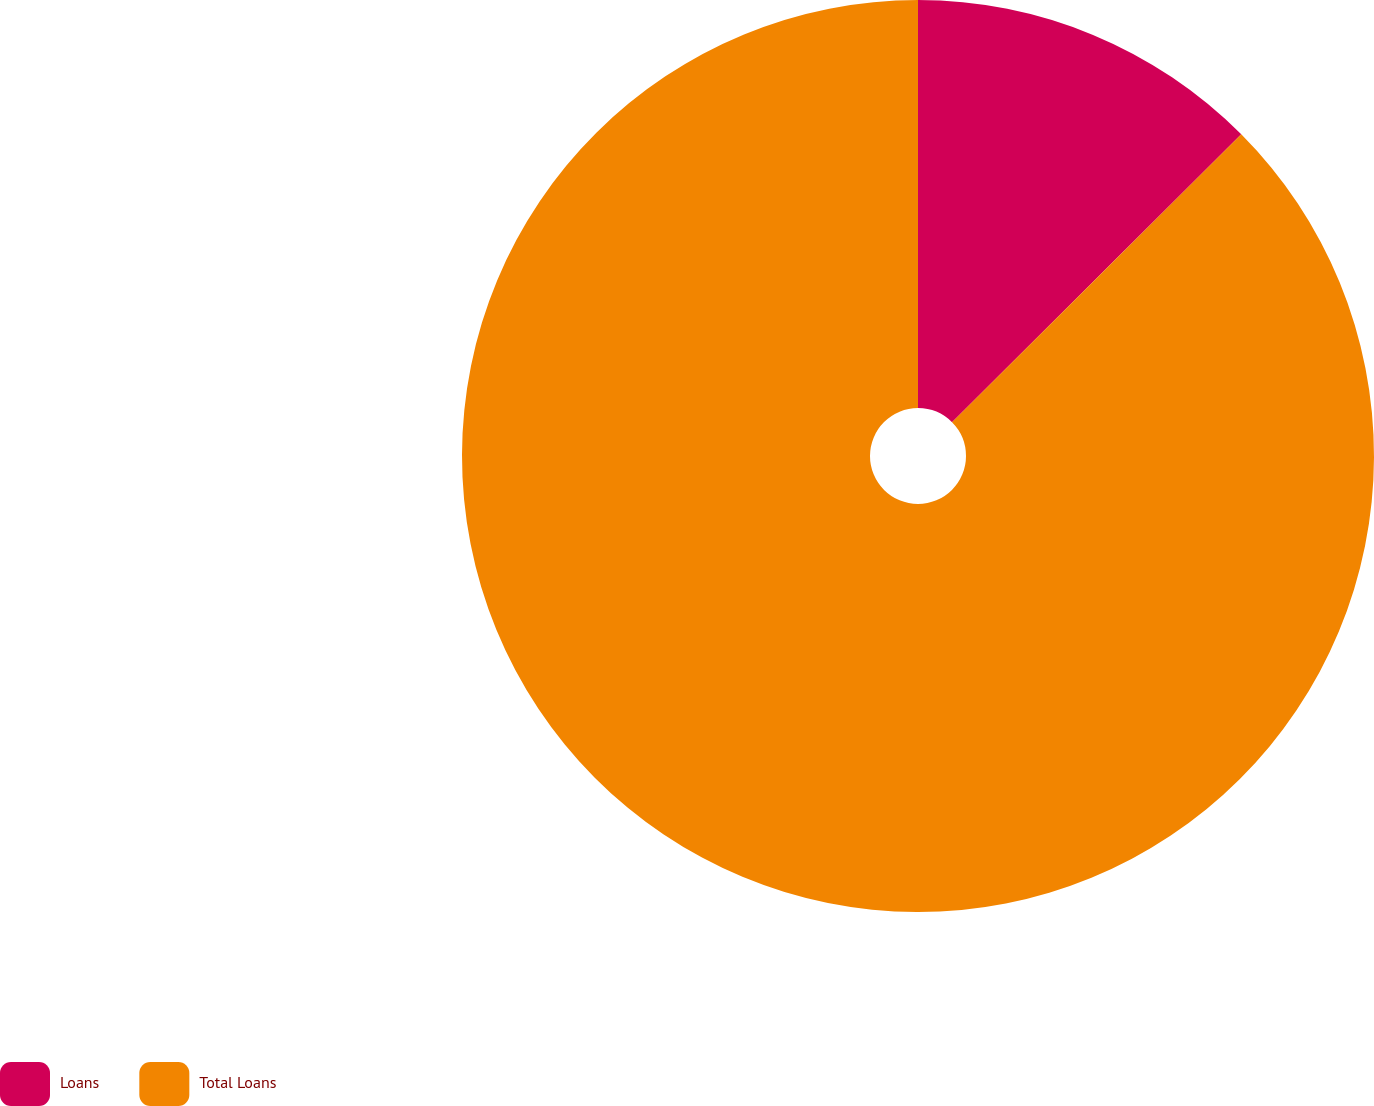<chart> <loc_0><loc_0><loc_500><loc_500><pie_chart><fcel>Loans<fcel>Total Loans<nl><fcel>12.54%<fcel>87.46%<nl></chart> 